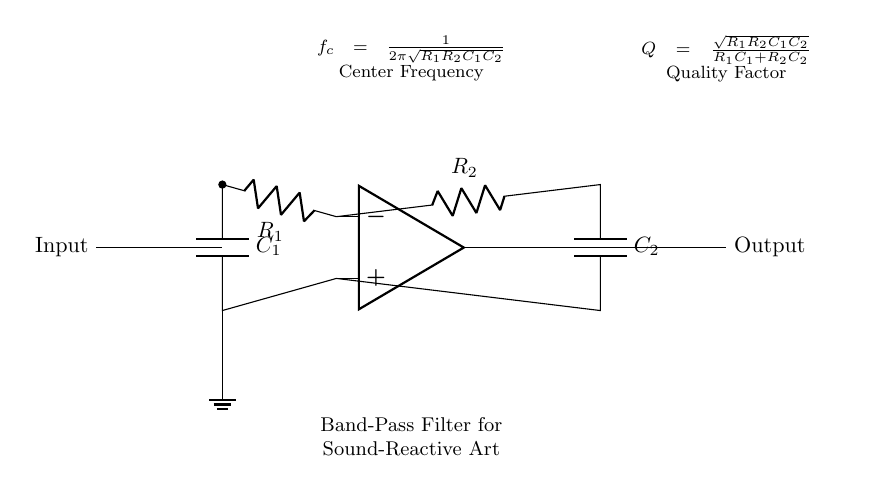What components are used in the band-pass filter? The components in the diagram are two resistors (R1 and R2) and two capacitors (C1 and C2) connected to an operational amplifier.
Answer: Resistors and capacitors What is the output of the band-pass filter? The output of the circuit is taken from the output terminal of the operational amplifier, designated as "Output" in the diagram.
Answer: Output What is the center frequency formula for this filter? The center frequency is given in the diagram as f_c = 1/(2π√(R1R2C1C2)), indicating the relationship between the resistors and capacitors.
Answer: f_c = 1/(2π√(R1R2C1C2)) What is the quality factor formula for the band-pass filter? The quality factor Q is shown in the diagram as Q = √(R1R2C1C2)/(R1C1 + R2C2), describing the filter's selectivity.
Answer: Q = √(R1R2C1C2)/(R1C1 + R2C2) How many energy storage elements are present in the circuit? There are two energy storage elements, which are the capacitors C1 and C2, responsible for determining the frequency response of the filter.
Answer: Two Which component determines the center frequency in the filter? The center frequency is influenced by the values of the resistors R1, R2 and the capacitors C1, C2, as indicated in the center frequency formula.
Answer: Resistors and capacitors 